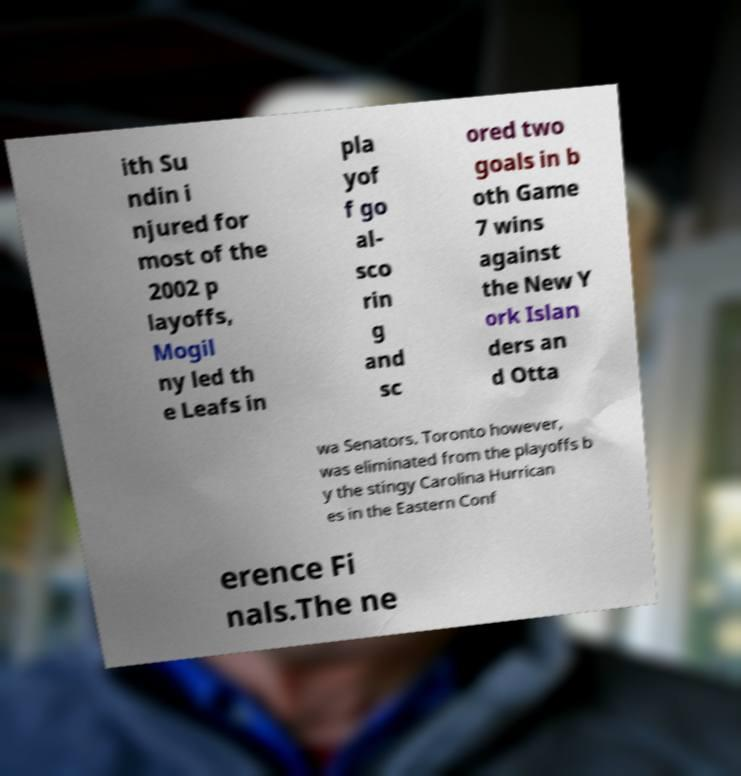Could you assist in decoding the text presented in this image and type it out clearly? ith Su ndin i njured for most of the 2002 p layoffs, Mogil ny led th e Leafs in pla yof f go al- sco rin g and sc ored two goals in b oth Game 7 wins against the New Y ork Islan ders an d Otta wa Senators. Toronto however, was eliminated from the playoffs b y the stingy Carolina Hurrican es in the Eastern Conf erence Fi nals.The ne 